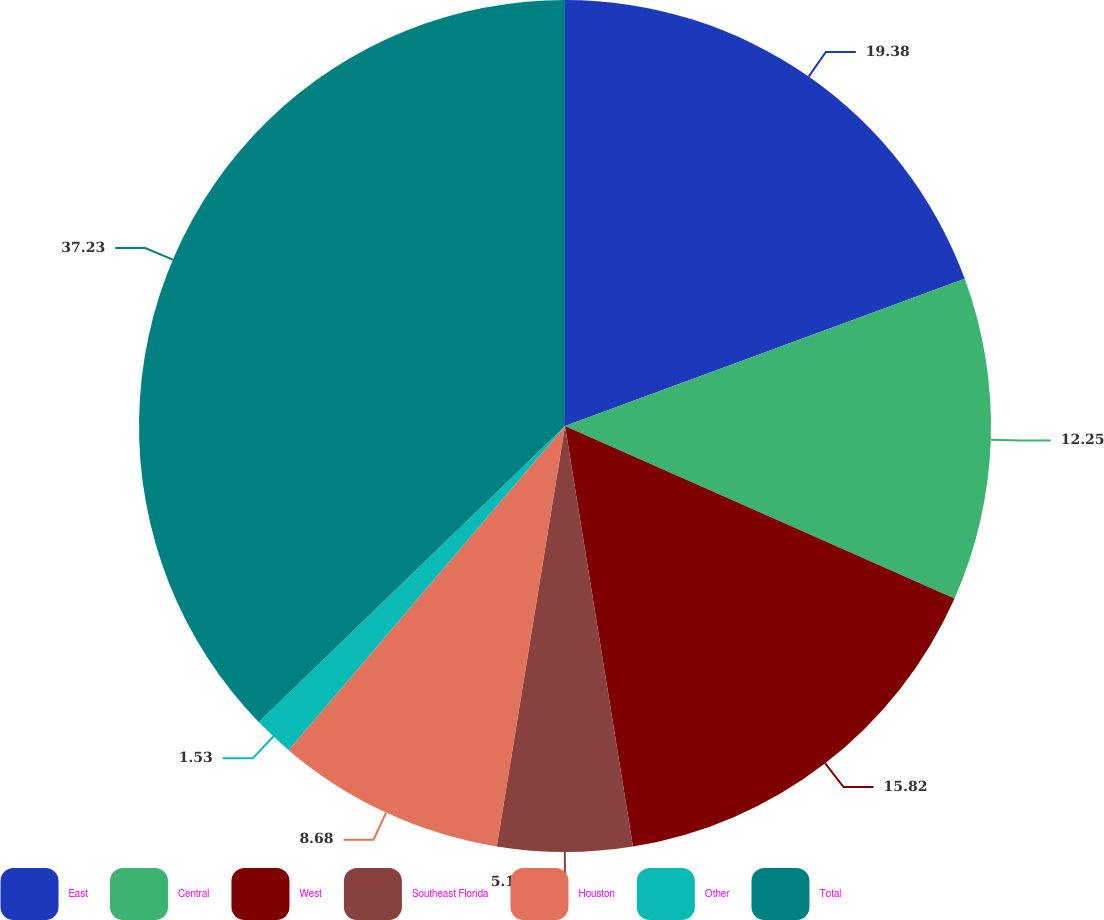<chart> <loc_0><loc_0><loc_500><loc_500><pie_chart><fcel>East<fcel>Central<fcel>West<fcel>Southeast Florida<fcel>Houston<fcel>Other<fcel>Total<nl><fcel>19.39%<fcel>12.25%<fcel>15.82%<fcel>5.11%<fcel>8.68%<fcel>1.53%<fcel>37.24%<nl></chart> 